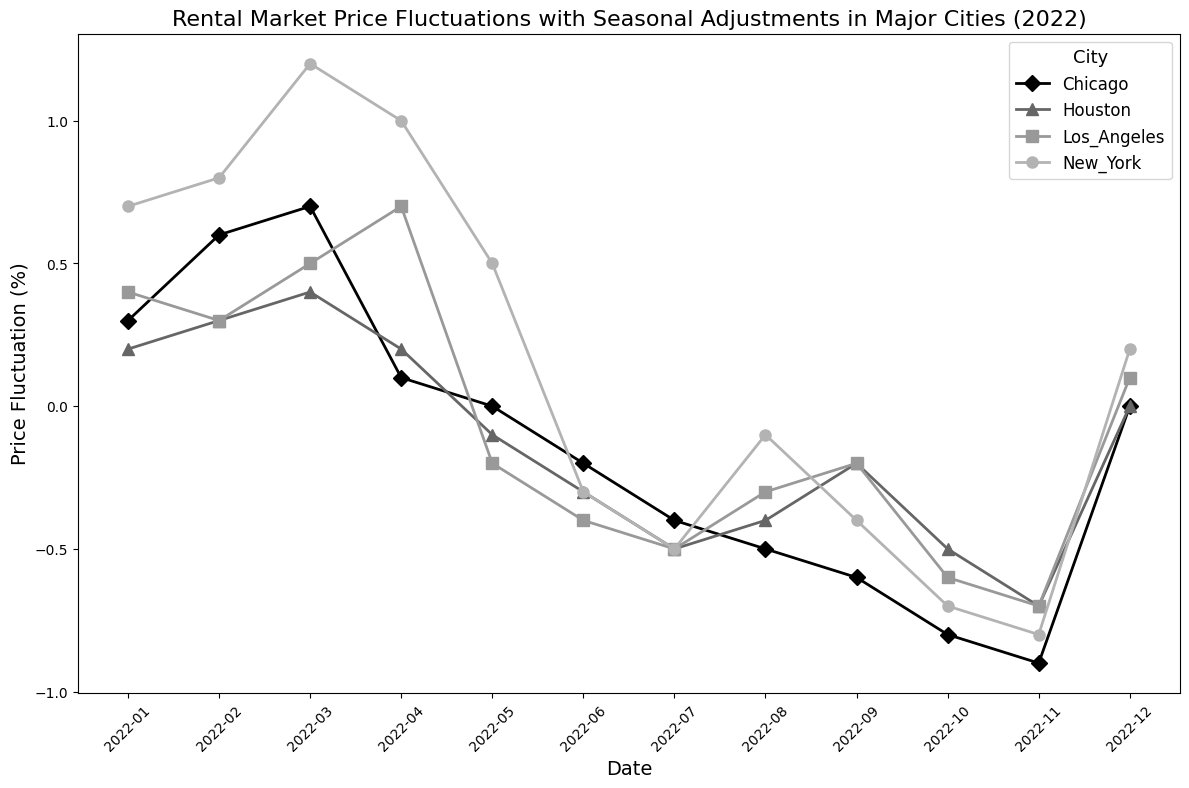Which city experienced the largest negative price fluctuation in December 2022? Identify the points on the plot for December 2022 and compare the price fluctuation values for all cities. The one with the most negative value is the answer.
Answer: Los_Angeles For which city did the price fluctuation decrease the most from February to October 2022? Compare the difference in price fluctuation for each city between February and October 2022. Find the city with the largest decrease.
Answer: New_York Which city had mostly positive price fluctuations for the first quarter of 2022? Look at the plotted points for January, February, and March 2022 for each city. Identify the city that had all positive values.
Answer: New_York Which city had the smallest fluctuation in November 2022? Identify the point for November 2022 for all cities and compare their values. The smallest fluctuation value is the answer.
Answer: Los_Angeles What is the difference between the highest price fluctuation in New York and Los Angeles in 2022? Identify the highest points for New York and Los Angeles on the plot, then calculate the difference between these two values.
Answer: 0.8 Which month has the highest average price fluctuation across all cities? Calculate the average price fluctuation for each month by summing the values for all cities and dividing by the number of cities. Identify the month with the highest average.
Answer: March Which city had the most consistent trend in price fluctuation, and how can you tell? Evaluate the stability and smoothness of the lines for each city. The city with minimal large fluctuations and a consistent pattern has the most consistent trend.
Answer: Houston Did any city have a positive price fluctuation for every month of the year? Check the plotted points for all cities across all months. Identify if any city only has positive values.
Answer: No What is the median price fluctuation for Chicago in 2022? List all the monthly price fluctuations for Chicago in ascending order and find the middle value. If it's an even number of values, average the two central numbers.
Answer: -0.2 